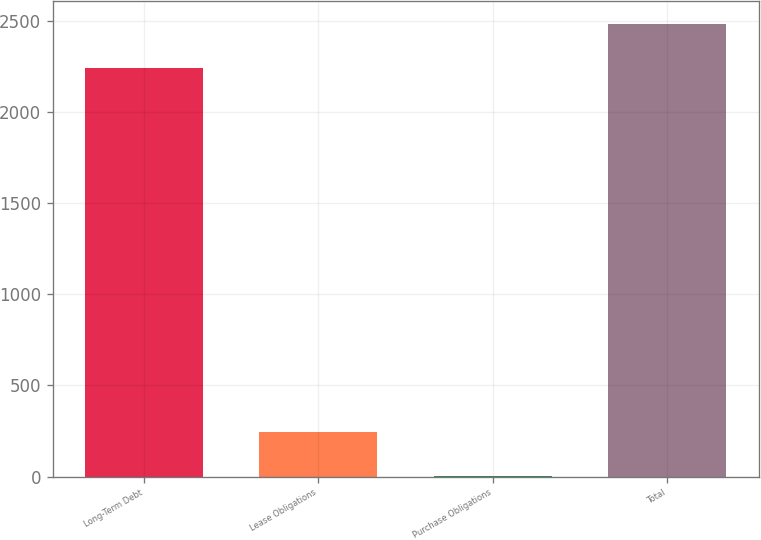Convert chart. <chart><loc_0><loc_0><loc_500><loc_500><bar_chart><fcel>Long-Term Debt<fcel>Lease Obligations<fcel>Purchase Obligations<fcel>Total<nl><fcel>2242.6<fcel>242.03<fcel>0.7<fcel>2483.93<nl></chart> 